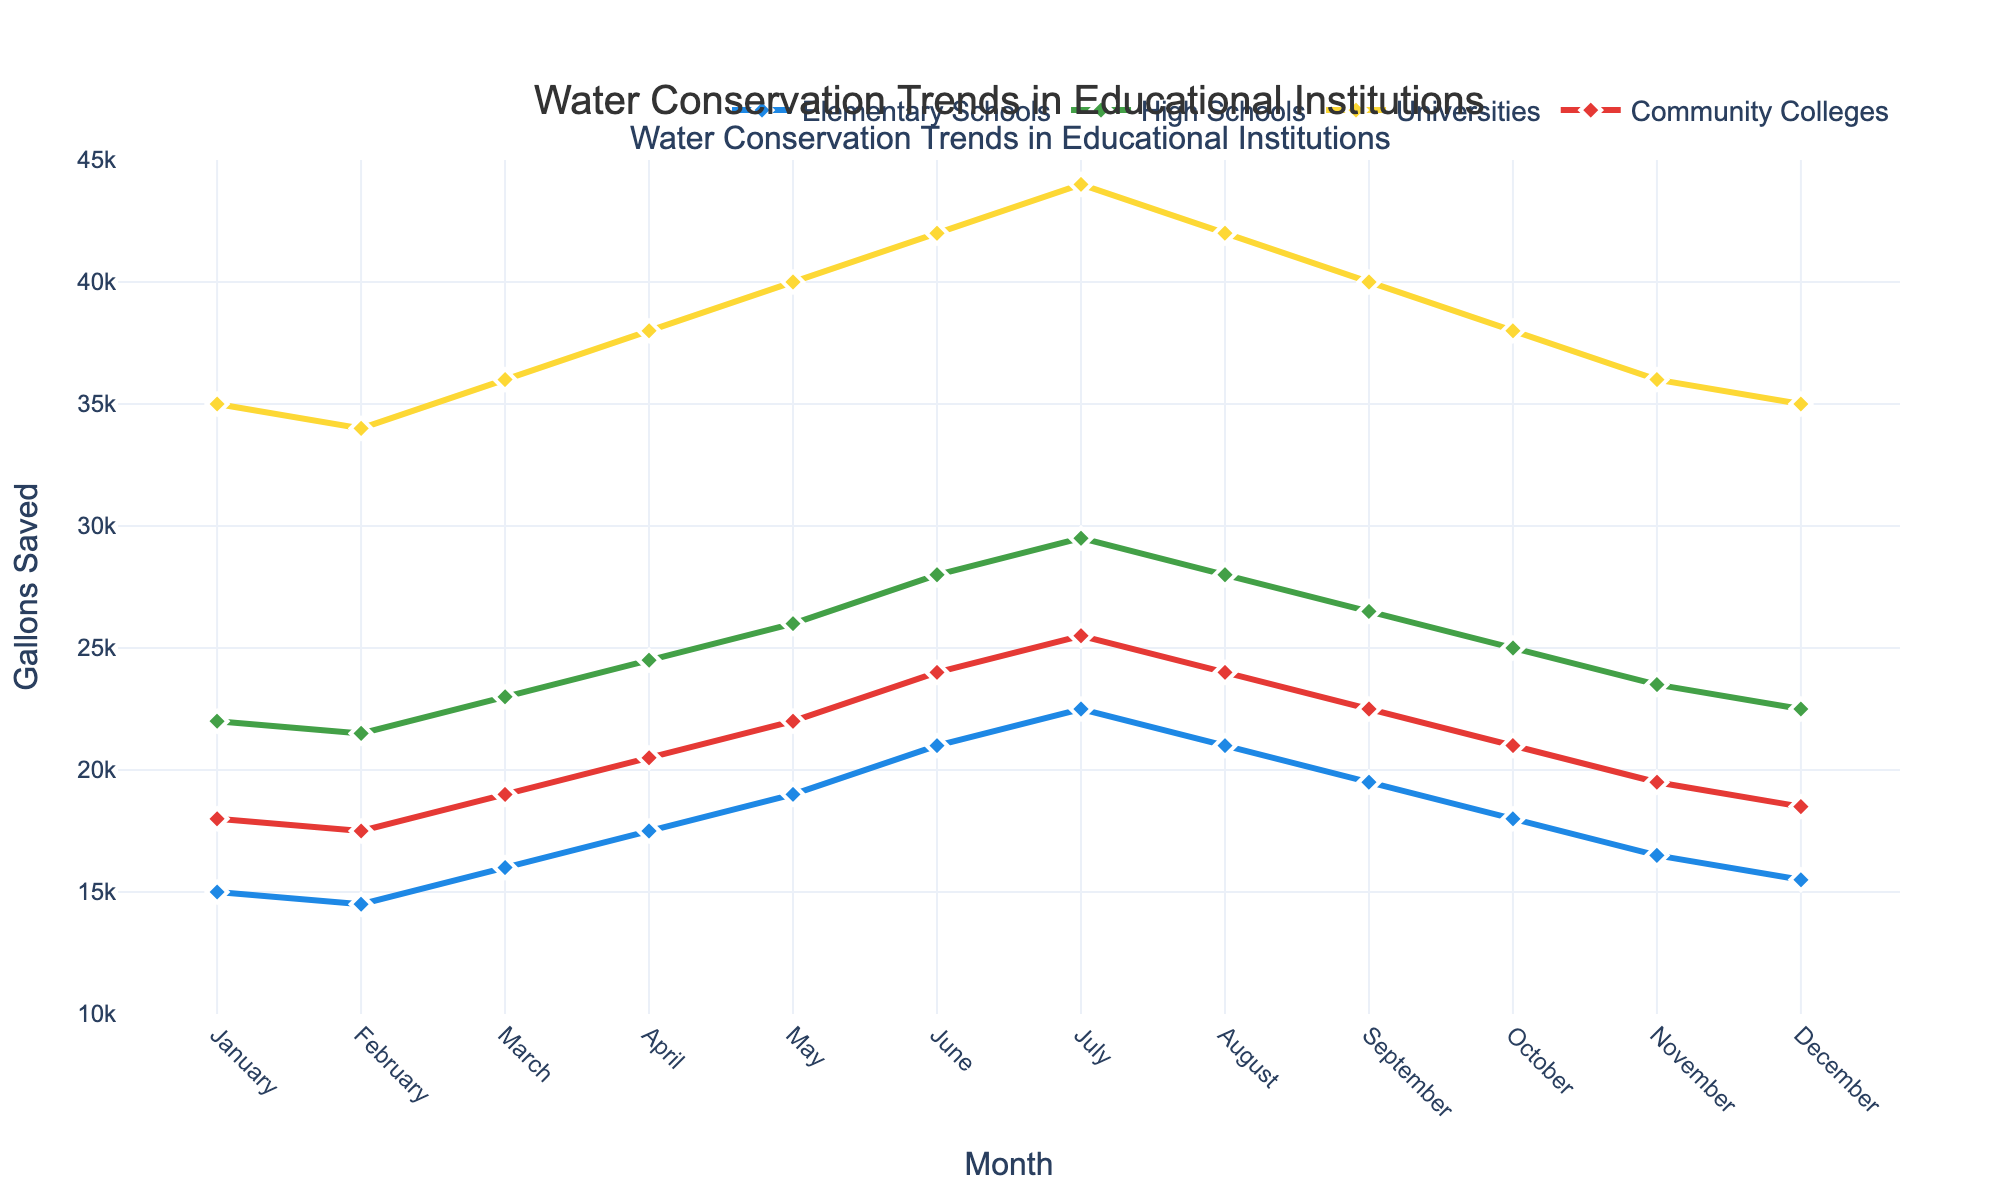what month had the highest water savings in Universities? Look at the Universities line in the plot, identify the peak point. July shows the highest value.
Answer: July compare the gallons saved in Elementary Schools and High Schools in March. Which institution saved more water? Locate March on the x-axis and compare the y-values of the Elementary Schools and High Schools lines. High Schools (23,000 gallons) saved more than Elementary Schools (16,000 gallons).
Answer: High Schools what is the average water saved by Community Colleges in the first quarter (January-March)? Add the water saved in January, February, and March for Community Colleges (18,000 + 17,500 + 19,000) and divide by 3.
Answer: 18,166.67 gallons did any institution show an overall increase in water savings over the year? Observe the general trend for each institution type over the span from January to December. All institutions show a peak in summer then decline, so none have an overall increase across the year.
Answer: No how does the water savings trend differ between Elementary Schools and Universities? The Elementary Schools trend shows a steady increase until July, then declines. Universities also peak in July but show larger variations and slightly higher overall savings.
Answer: Steady incline and decline for Elementary Schools, larger variations for Universities in which month did Community Colleges save the least amount of water, and how many gallons were saved? Locate the minimum y-value of the Community Colleges line. February shows the lowest value.
Answer: February, 17,500 gallons calculate the total water savings for High Schools from June to August. Sum the water savings for High Schools in June, July, and August (28,000 + 29,500 + 28,000).
Answer: 85,500 gallons which institution saved more water in October: Elementary Schools or Community Colleges? Compare the y-values for October between Elementary Schools (18,000 gallons) and Community Colleges (21,000 gallons).
Answer: Community Colleges estimate the total water savings for all institutions in December. Sum the corresponding values in December for each institution. (15,500 + 22,500 + 35,000 + 18,500).
Answer: 91,500 gallons what is the difference in water saved between May and November for High Schools? Find the water saved in High Schools for May and November, then subtract the November value from the May value. (26,000 - 23,500).
Answer: 2,500 gallons 